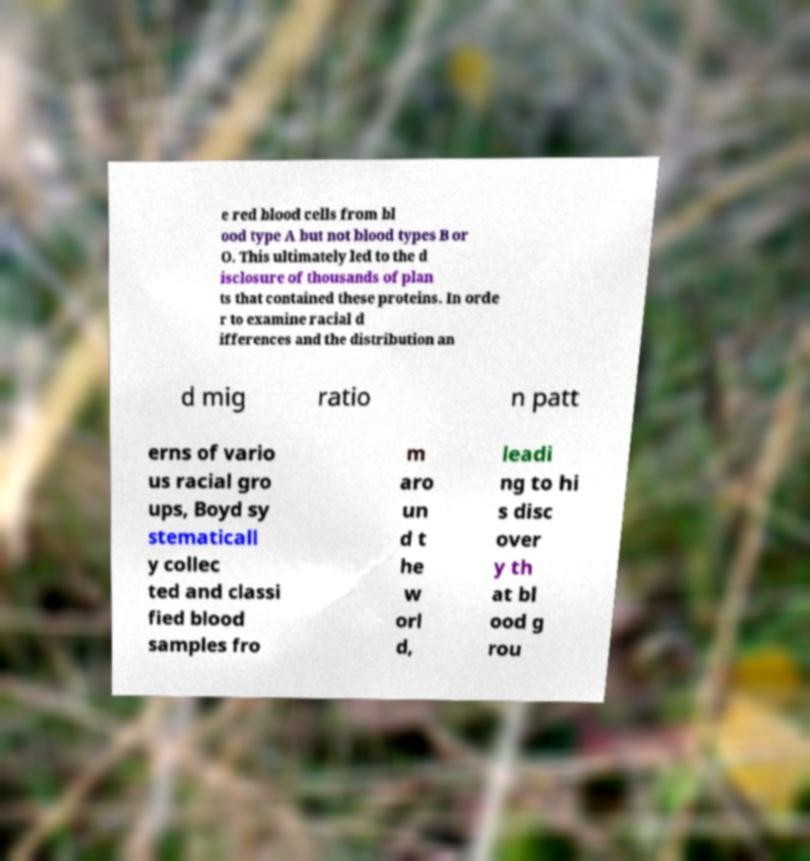Could you extract and type out the text from this image? e red blood cells from bl ood type A but not blood types B or O. This ultimately led to the d isclosure of thousands of plan ts that contained these proteins. In orde r to examine racial d ifferences and the distribution an d mig ratio n patt erns of vario us racial gro ups, Boyd sy stematicall y collec ted and classi fied blood samples fro m aro un d t he w orl d, leadi ng to hi s disc over y th at bl ood g rou 